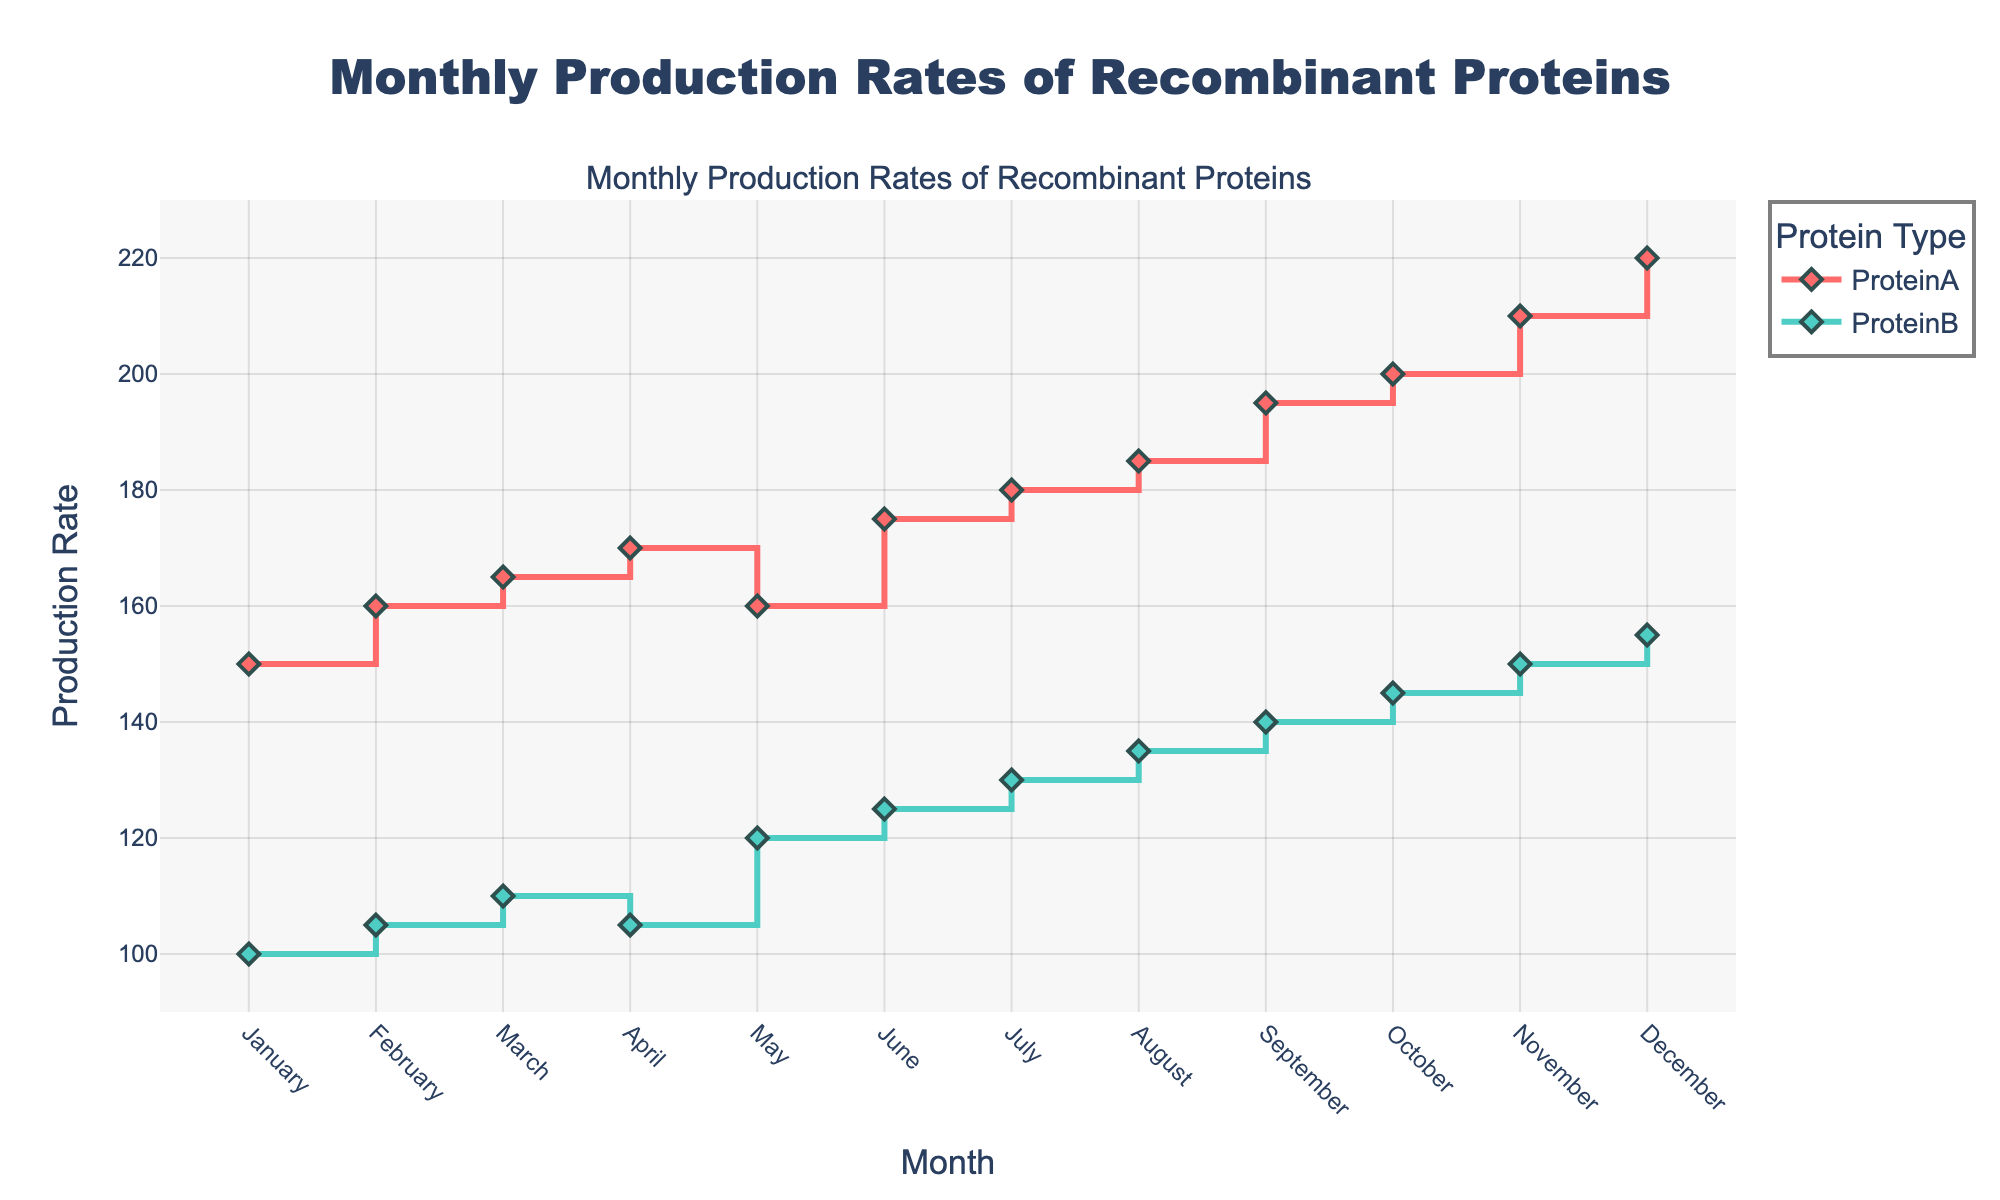What is the title of the plot? The title of the plot is displayed at the top of the figure and reads "Monthly Production Rates of Recombinant Proteins".
Answer: Monthly Production Rates of Recombinant Proteins Which protein has the highest production rate in December? By examining the plot, ProteinA shows the highest production rate in December, which is indicated at the top of the stair plot for ProteinA.
Answer: ProteinA How does the production rate of ProteinA change from January to December? Starting at 150 in January, the production rate of ProteinA increases monthly, reaching a maximum of 220 in December. This is observed from the upward trend in the stair plot for ProteinA.
Answer: It increases What is the average production rate of ProteinB over the year? The average production rate can be calculated by summing the monthly rates (100 + 105 + 110 + 105 + 120 + 125 + 130 + 135 + 140 + 145 + 150 + 155) and dividing by 12. The total is 1420, so the average is 1420/12 = 118.33.
Answer: 118.33 In which month do ProteinA and ProteinB experience a drop in production rate compared to the previous month? Both proteins experience production rate drops in different months. ProteinA drops from April (170) to May (160), while ProteinB drops from March (110) to April (105), which can be seen from the downward steps in the respective plots.
Answer: ProteinA in May, ProteinB in April Compare the production rates of ProteinA and ProteinB in July. Which protein has a higher production rate and by how much? In July, ProteinA has a production rate of 180 and ProteinB has 130. The difference is 180 - 130 = 50, so ProteinA has a higher production rate by 50 units.
Answer: ProteinA by 50 units What is the trend of production rates for both proteins over the months? Both ProteinA and ProteinB show a general upward trend in production rates over the months, as reflected in the increasing steps of their stair plots.
Answer: Upward trend Which month shows the greatest increase in production rate for ProteinA? The greatest increase for ProteinA is from September (195) to October (200), an increase of 5 units. This can be identified by noting the differences in the height of the steps between consecutive months.
Answer: October What's the difference in production rates between ProteinA and ProteinB in November? In November, ProteinA has a rate of 210 and ProteinB has 150. The difference is 210 - 150 = 60.
Answer: 60 By how much does the production rate of ProteinB increase from January to December? The production rate of ProteinB in January is 100 and in December it is 155. The increase is 155 - 100 = 55.
Answer: 55 